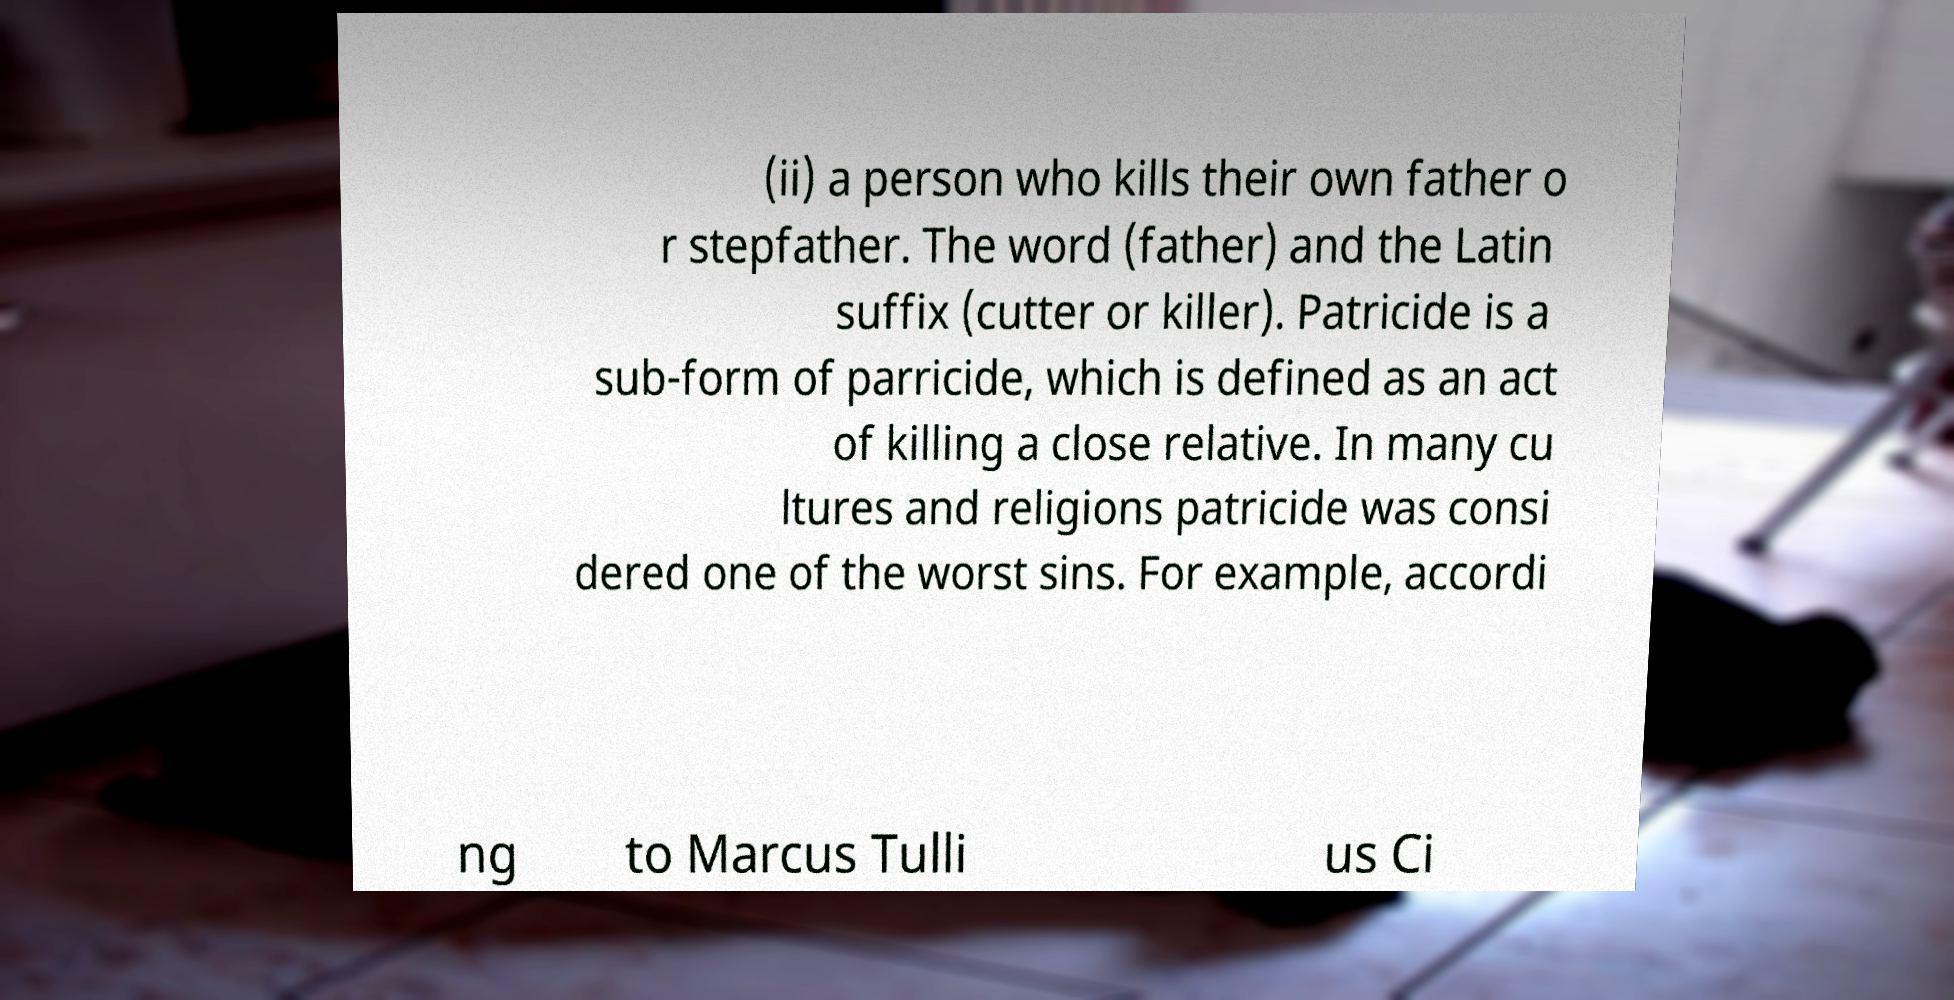Please identify and transcribe the text found in this image. (ii) a person who kills their own father o r stepfather. The word (father) and the Latin suffix (cutter or killer). Patricide is a sub-form of parricide, which is defined as an act of killing a close relative. In many cu ltures and religions patricide was consi dered one of the worst sins. For example, accordi ng to Marcus Tulli us Ci 